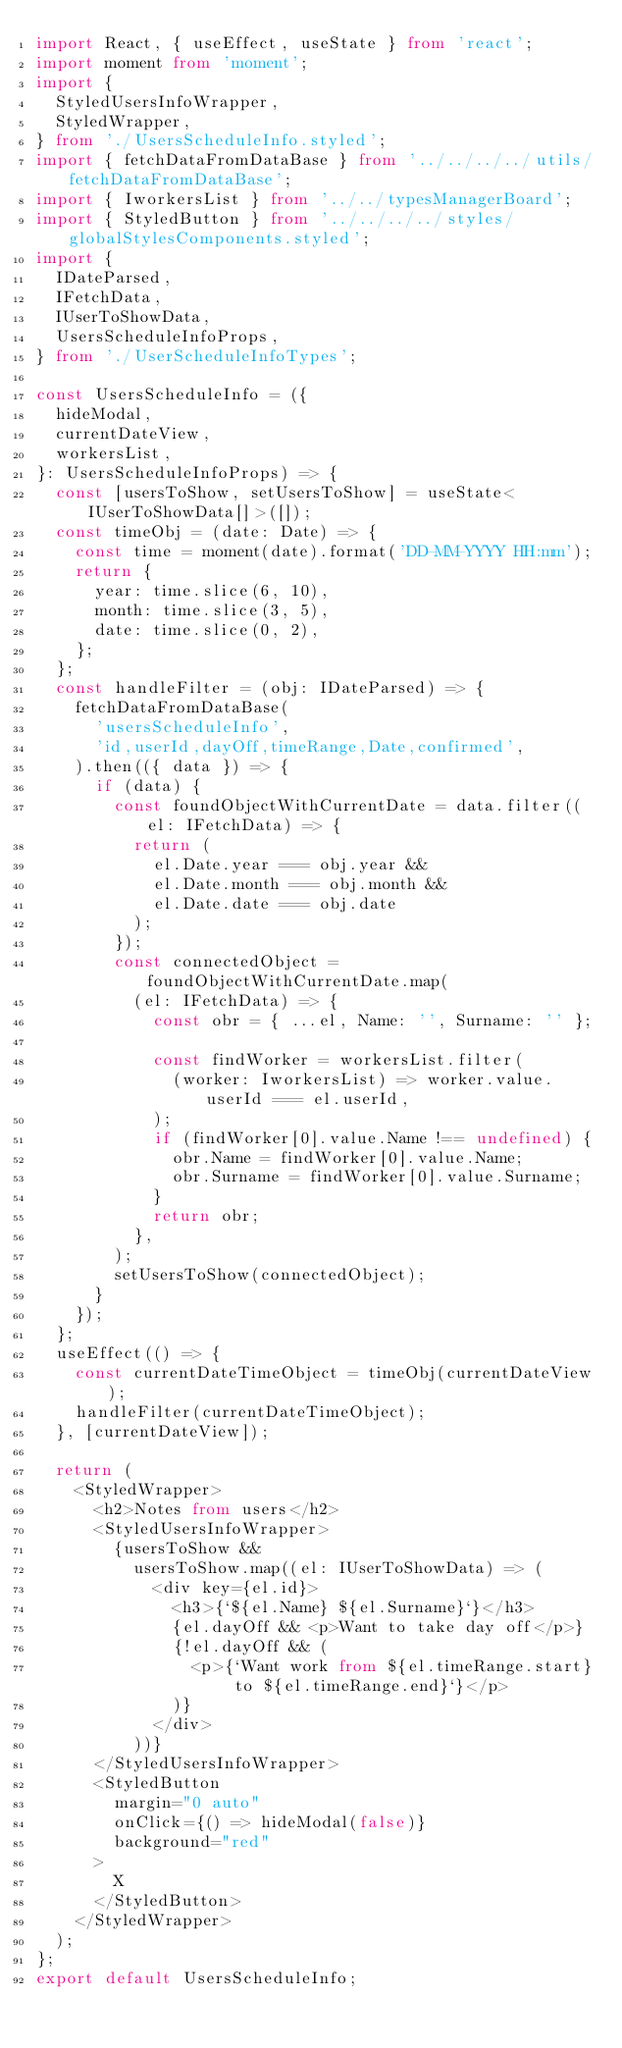<code> <loc_0><loc_0><loc_500><loc_500><_TypeScript_>import React, { useEffect, useState } from 'react';
import moment from 'moment';
import {
  StyledUsersInfoWrapper,
  StyledWrapper,
} from './UsersScheduleInfo.styled';
import { fetchDataFromDataBase } from '../../../../utils/fetchDataFromDataBase';
import { IworkersList } from '../../typesManagerBoard';
import { StyledButton } from '../../../../styles/globalStylesComponents.styled';
import {
  IDateParsed,
  IFetchData,
  IUserToShowData,
  UsersScheduleInfoProps,
} from './UserScheduleInfoTypes';

const UsersScheduleInfo = ({
  hideModal,
  currentDateView,
  workersList,
}: UsersScheduleInfoProps) => {
  const [usersToShow, setUsersToShow] = useState<IUserToShowData[]>([]);
  const timeObj = (date: Date) => {
    const time = moment(date).format('DD-MM-YYYY HH:mm');
    return {
      year: time.slice(6, 10),
      month: time.slice(3, 5),
      date: time.slice(0, 2),
    };
  };
  const handleFilter = (obj: IDateParsed) => {
    fetchDataFromDataBase(
      'usersScheduleInfo',
      'id,userId,dayOff,timeRange,Date,confirmed',
    ).then(({ data }) => {
      if (data) {
        const foundObjectWithCurrentDate = data.filter((el: IFetchData) => {
          return (
            el.Date.year === obj.year &&
            el.Date.month === obj.month &&
            el.Date.date === obj.date
          );
        });
        const connectedObject = foundObjectWithCurrentDate.map(
          (el: IFetchData) => {
            const obr = { ...el, Name: '', Surname: '' };

            const findWorker = workersList.filter(
              (worker: IworkersList) => worker.value.userId === el.userId,
            );
            if (findWorker[0].value.Name !== undefined) {
              obr.Name = findWorker[0].value.Name;
              obr.Surname = findWorker[0].value.Surname;
            }
            return obr;
          },
        );
        setUsersToShow(connectedObject);
      }
    });
  };
  useEffect(() => {
    const currentDateTimeObject = timeObj(currentDateView);
    handleFilter(currentDateTimeObject);
  }, [currentDateView]);

  return (
    <StyledWrapper>
      <h2>Notes from users</h2>
      <StyledUsersInfoWrapper>
        {usersToShow &&
          usersToShow.map((el: IUserToShowData) => (
            <div key={el.id}>
              <h3>{`${el.Name} ${el.Surname}`}</h3>
              {el.dayOff && <p>Want to take day off</p>}
              {!el.dayOff && (
                <p>{`Want work from ${el.timeRange.start} to ${el.timeRange.end}`}</p>
              )}
            </div>
          ))}
      </StyledUsersInfoWrapper>
      <StyledButton
        margin="0 auto"
        onClick={() => hideModal(false)}
        background="red"
      >
        X
      </StyledButton>
    </StyledWrapper>
  );
};
export default UsersScheduleInfo;
</code> 